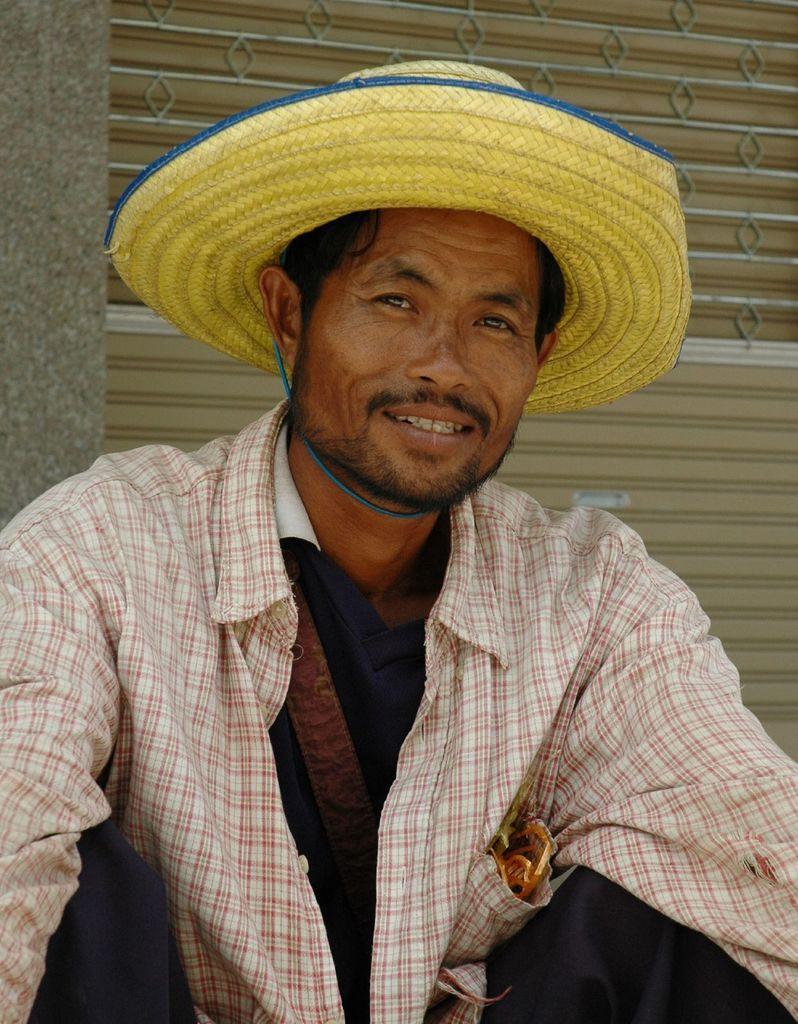Can you describe this image briefly? In the center of the image we can see a person in a different costume and he is smiling. And we can see he is wearing a hat. And we can see some object in his pocket. In the background there is a wall and a shutter. 